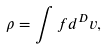Convert formula to latex. <formula><loc_0><loc_0><loc_500><loc_500>\rho = \int f d ^ { D } { v } ,</formula> 